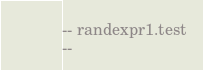Convert code to text. <code><loc_0><loc_0><loc_500><loc_500><_SQL_>-- randexpr1.test
-- </code> 